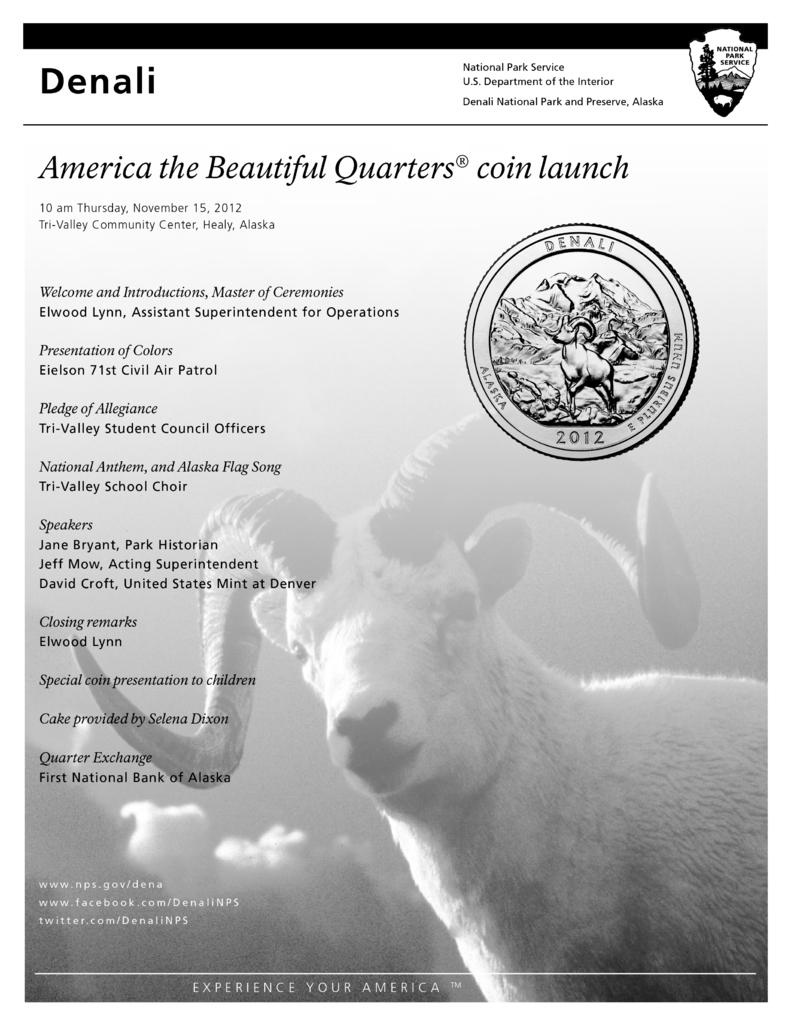What is present in the image that contains information? There is a pamphlet in the image. What can be found on the pamphlet? There is writing on the pamphlet. What color is the writing on the pamphlet? The writing on the pamphlet is in black color. How does the jellyfish feel about the attraction in the image? There is no jellyfish or attraction present in the image, so it is not possible to answer that question. 